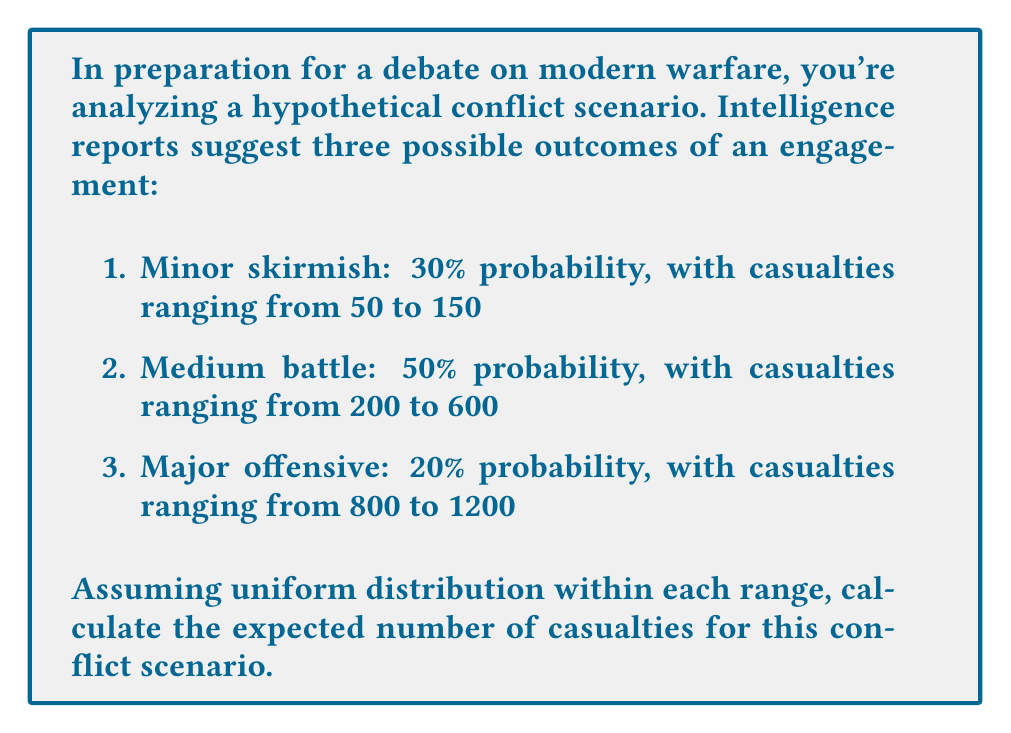Provide a solution to this math problem. To solve this problem, we'll follow these steps:

1. Calculate the average casualties for each scenario:
   a) Minor skirmish: $\frac{50 + 150}{2} = 100$
   b) Medium battle: $\frac{200 + 600}{2} = 400$
   c) Major offensive: $\frac{800 + 1200}{2} = 1000$

2. Calculate the expected value using the probability of each scenario and its average casualties:

   $$E(\text{casualties}) = P(\text{minor}) \cdot E(\text{minor}) + P(\text{medium}) \cdot E(\text{medium}) + P(\text{major}) \cdot E(\text{major})$$

   Where $P$ represents the probability and $E$ represents the average (expected) casualties for each scenario.

3. Substitute the values:

   $$E(\text{casualties}) = 0.30 \cdot 100 + 0.50 \cdot 400 + 0.20 \cdot 1000$$

4. Perform the calculations:

   $$E(\text{casualties}) = 30 + 200 + 200 = 430$$

Therefore, the expected number of casualties in this hypothetical conflict scenario is 430.
Answer: 430 casualties 